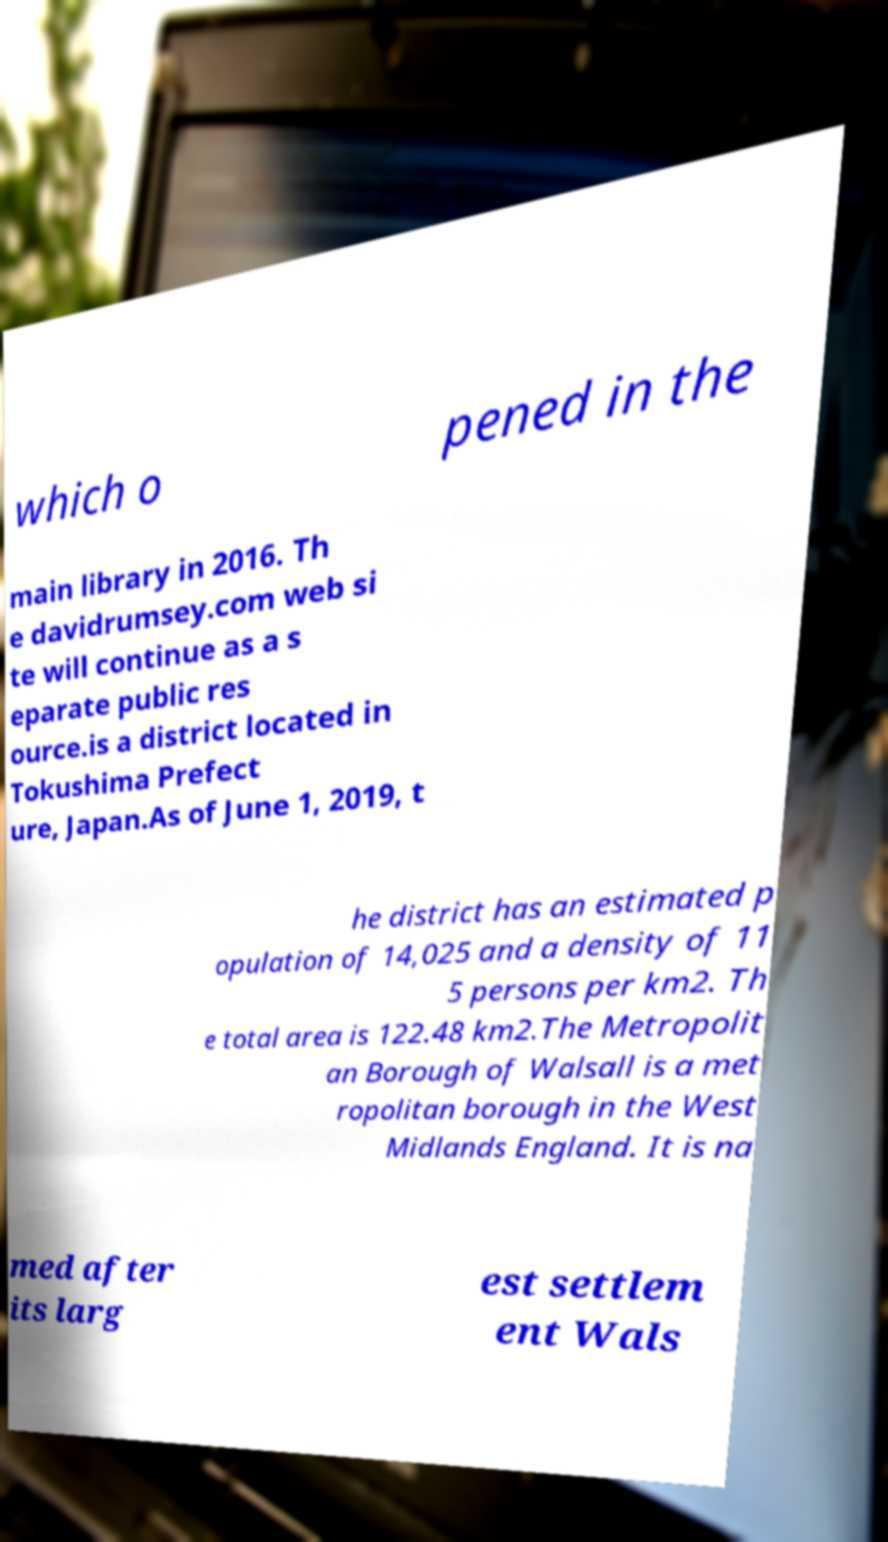Please read and relay the text visible in this image. What does it say? which o pened in the main library in 2016. Th e davidrumsey.com web si te will continue as a s eparate public res ource.is a district located in Tokushima Prefect ure, Japan.As of June 1, 2019, t he district has an estimated p opulation of 14,025 and a density of 11 5 persons per km2. Th e total area is 122.48 km2.The Metropolit an Borough of Walsall is a met ropolitan borough in the West Midlands England. It is na med after its larg est settlem ent Wals 